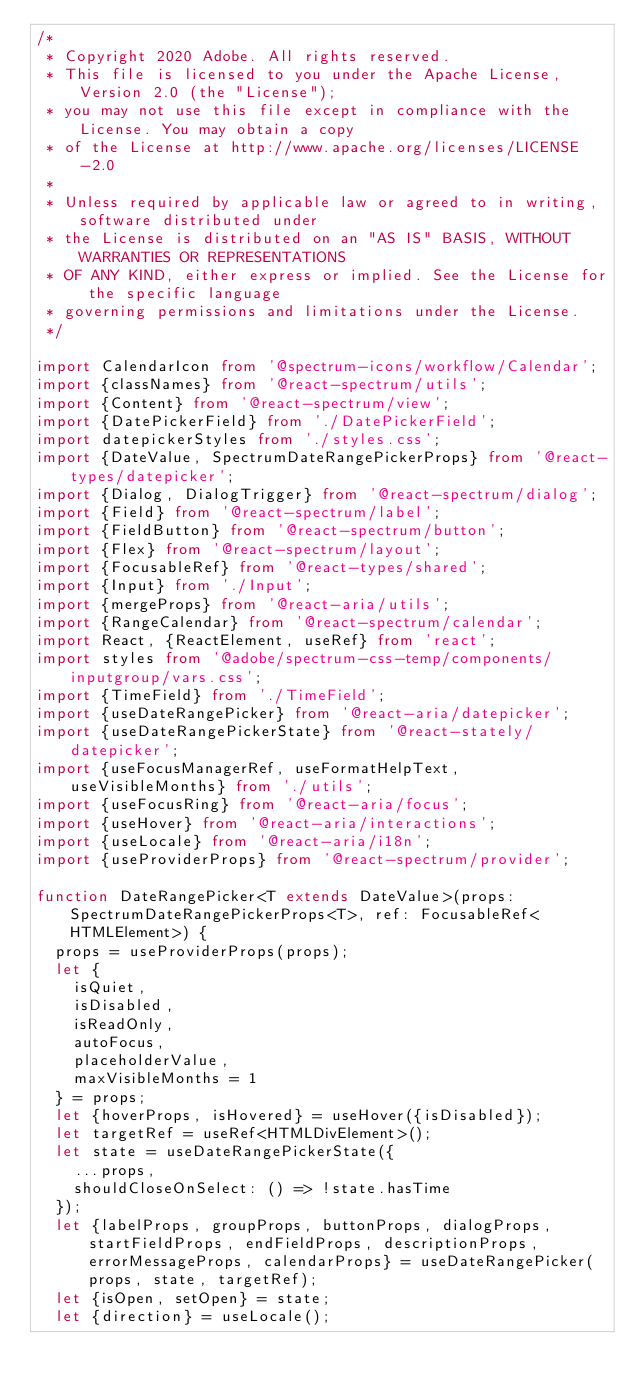Convert code to text. <code><loc_0><loc_0><loc_500><loc_500><_TypeScript_>/*
 * Copyright 2020 Adobe. All rights reserved.
 * This file is licensed to you under the Apache License, Version 2.0 (the "License");
 * you may not use this file except in compliance with the License. You may obtain a copy
 * of the License at http://www.apache.org/licenses/LICENSE-2.0
 *
 * Unless required by applicable law or agreed to in writing, software distributed under
 * the License is distributed on an "AS IS" BASIS, WITHOUT WARRANTIES OR REPRESENTATIONS
 * OF ANY KIND, either express or implied. See the License for the specific language
 * governing permissions and limitations under the License.
 */

import CalendarIcon from '@spectrum-icons/workflow/Calendar';
import {classNames} from '@react-spectrum/utils';
import {Content} from '@react-spectrum/view';
import {DatePickerField} from './DatePickerField';
import datepickerStyles from './styles.css';
import {DateValue, SpectrumDateRangePickerProps} from '@react-types/datepicker';
import {Dialog, DialogTrigger} from '@react-spectrum/dialog';
import {Field} from '@react-spectrum/label';
import {FieldButton} from '@react-spectrum/button';
import {Flex} from '@react-spectrum/layout';
import {FocusableRef} from '@react-types/shared';
import {Input} from './Input';
import {mergeProps} from '@react-aria/utils';
import {RangeCalendar} from '@react-spectrum/calendar';
import React, {ReactElement, useRef} from 'react';
import styles from '@adobe/spectrum-css-temp/components/inputgroup/vars.css';
import {TimeField} from './TimeField';
import {useDateRangePicker} from '@react-aria/datepicker';
import {useDateRangePickerState} from '@react-stately/datepicker';
import {useFocusManagerRef, useFormatHelpText, useVisibleMonths} from './utils';
import {useFocusRing} from '@react-aria/focus';
import {useHover} from '@react-aria/interactions';
import {useLocale} from '@react-aria/i18n';
import {useProviderProps} from '@react-spectrum/provider';

function DateRangePicker<T extends DateValue>(props: SpectrumDateRangePickerProps<T>, ref: FocusableRef<HTMLElement>) {
  props = useProviderProps(props);
  let {
    isQuiet,
    isDisabled,
    isReadOnly,
    autoFocus,
    placeholderValue,
    maxVisibleMonths = 1
  } = props;
  let {hoverProps, isHovered} = useHover({isDisabled});
  let targetRef = useRef<HTMLDivElement>();
  let state = useDateRangePickerState({
    ...props,
    shouldCloseOnSelect: () => !state.hasTime
  });
  let {labelProps, groupProps, buttonProps, dialogProps, startFieldProps, endFieldProps, descriptionProps, errorMessageProps, calendarProps} = useDateRangePicker(props, state, targetRef);
  let {isOpen, setOpen} = state;
  let {direction} = useLocale();</code> 